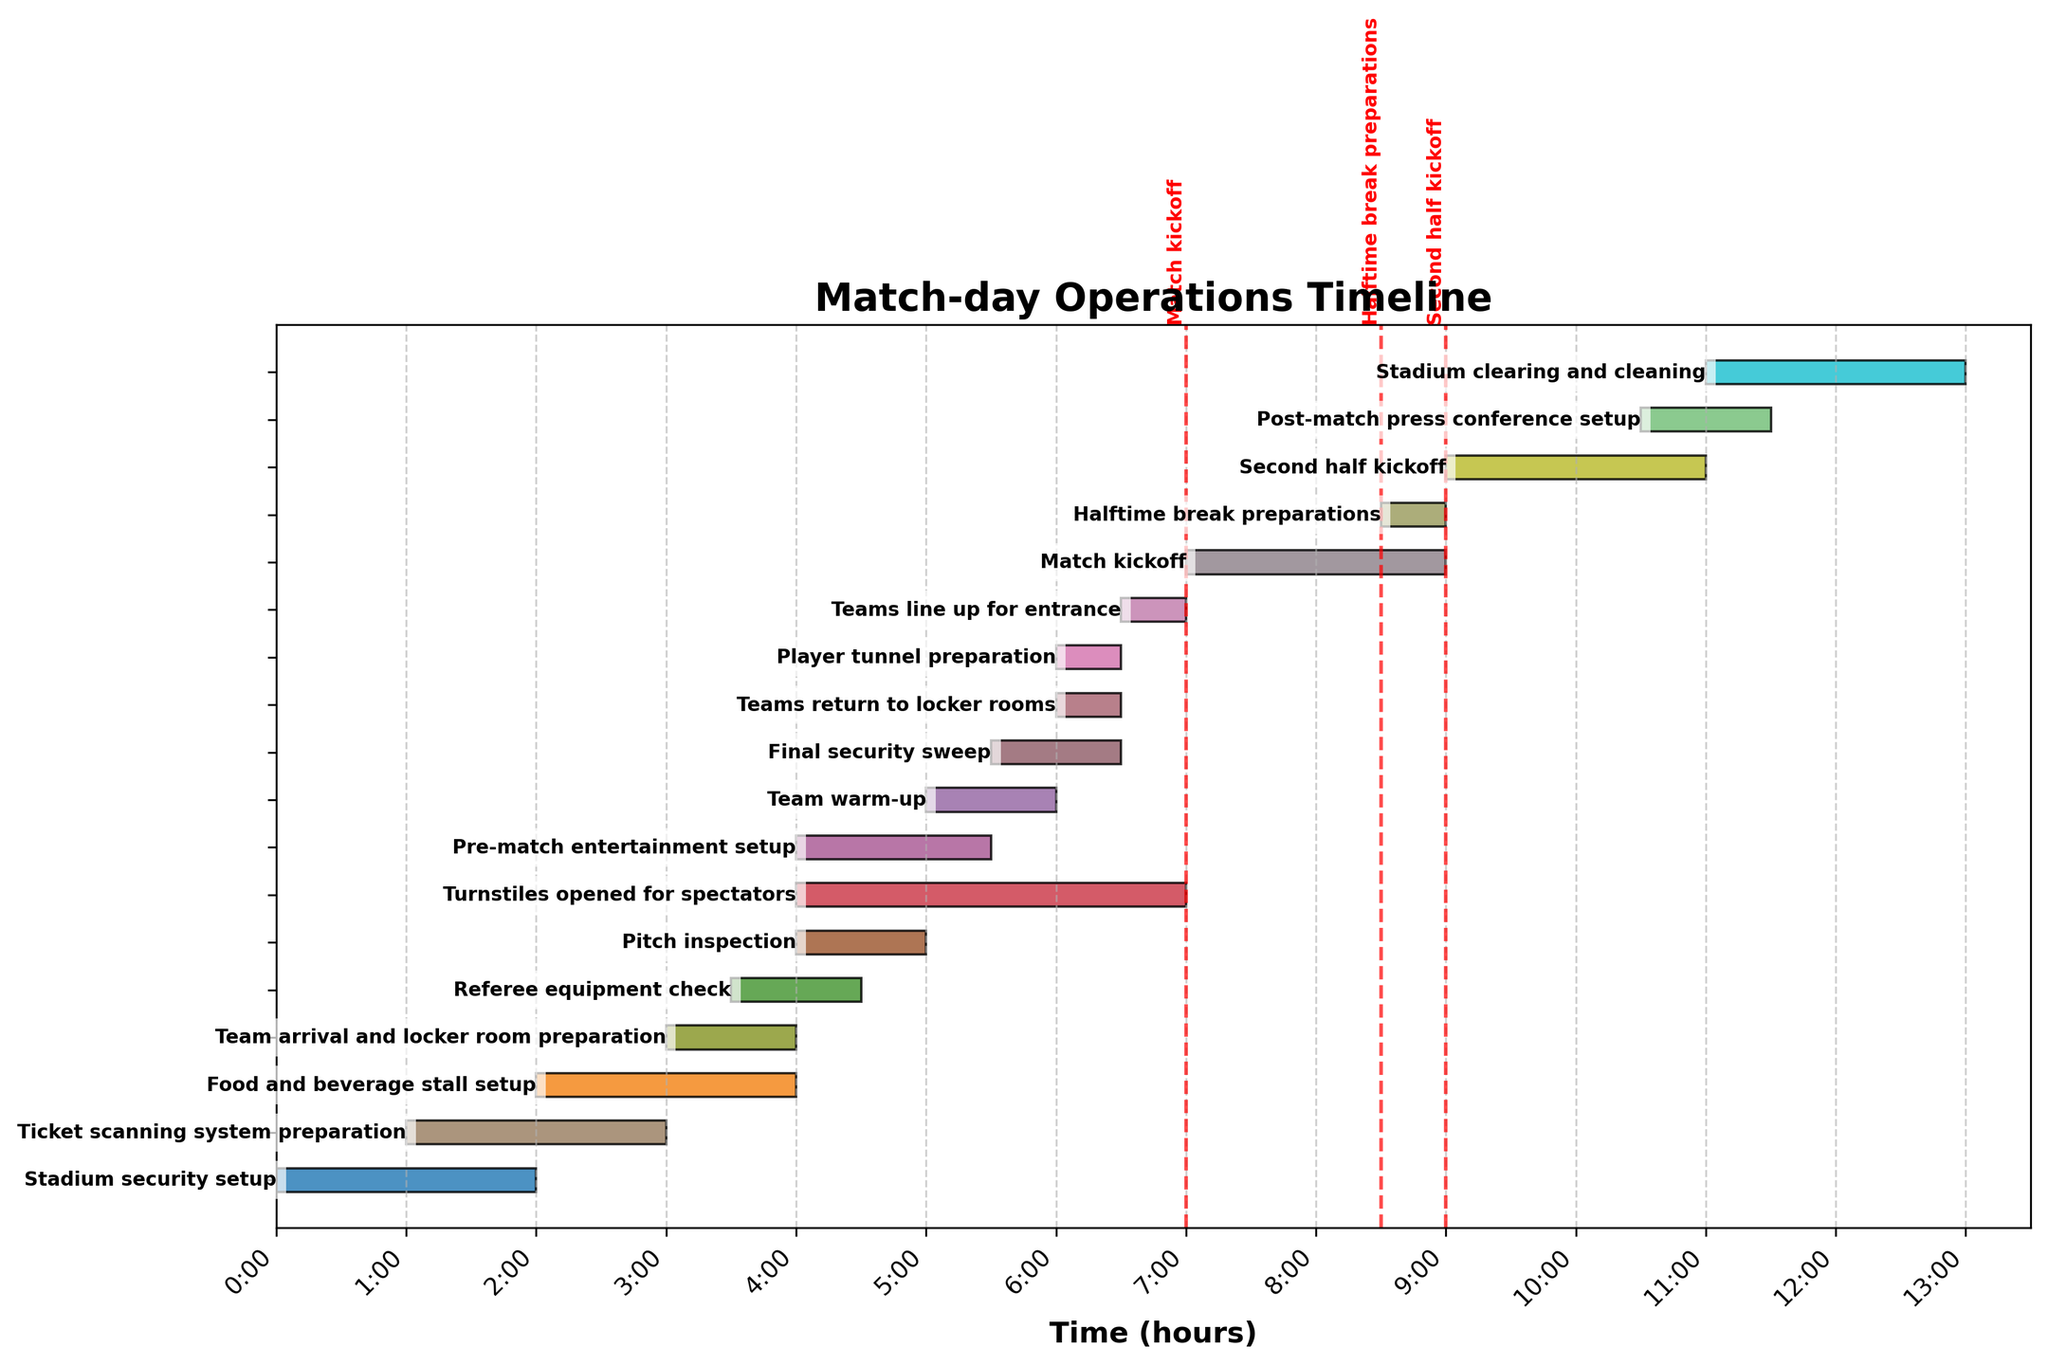What is the title of the Gantt Chart? The title is typically located at the top of the chart and provides a summary of the content it represents. In this case, it is “Match-day Operations Timeline.”
Answer: Match-day Operations Timeline How many tasks are involved in the whole match-day operation? Count the number of bars that represent each task in the Gantt Chart. Each bar corresponds to one unique task.
Answer: 18 At what time does the first task begin? Look for the leftmost bar on the Gantt Chart that represents the first task, and check its starting point on the x-axis. This task is "Stadium security setup."
Answer: 0 Which task starts immediately after the "Stadium security setup"? Find the task labeled "Stadium security setup," then identify the next task that begins right after it from the top left to the right direction. "Ticket scanning system preparation" starts at time 1.
Answer: Ticket scanning system preparation Which task has the longest duration? To identify the longest duration, compare the length of each bar in the chart. "Turnstiles opened for spectators" spans from time 4 to 7, totaling 3 units of time.
Answer: Turnstiles opened for spectators What duration do "Final security sweep" and "Teams return to locker rooms" overlap? Check the bars of "Final security sweep" (5.5 to 6.5) and "Teams return to locker rooms" (6 to 6.5). The overlapping period is from 6 to 6.5.
Answer: 0.5 hours Do "Team arrival and locker room preparation" and "Referee equipment check" occur at the same time? Verify if the ranges of "Team arrival and locker room preparation" (3 to 4) and "Referee equipment check" (3.5 to 4.5) overlap.
Answer: Yes How long after the "Turnstiles opened for spectators" does the "Match kickoff" happen? Calculate the time difference between the start of "Turnstiles opened for spectators" (4) and "Match kickoff" (7). The difference is 3 hours.
Answer: 3 hours Which pre-match task starts last before the pitch inspection? Identify the last task that starts before 4 (when "Pitch inspection" starts). "Referee equipment check" starts at 3.5, which is the last task before the inspection.
Answer: Referee equipment check What tasks are scheduled between 4 and 5.5 hours on the timeline? Identify and list all tasks that occur within the range of 4 to 5.5 on the timeline. They include "Pitch inspection," "Turnstiles opened for spectators," and "Pre-match entertainment setup."
Answer: Pitch inspection, Turnstiles opened for spectators, Pre-match entertainment setup 